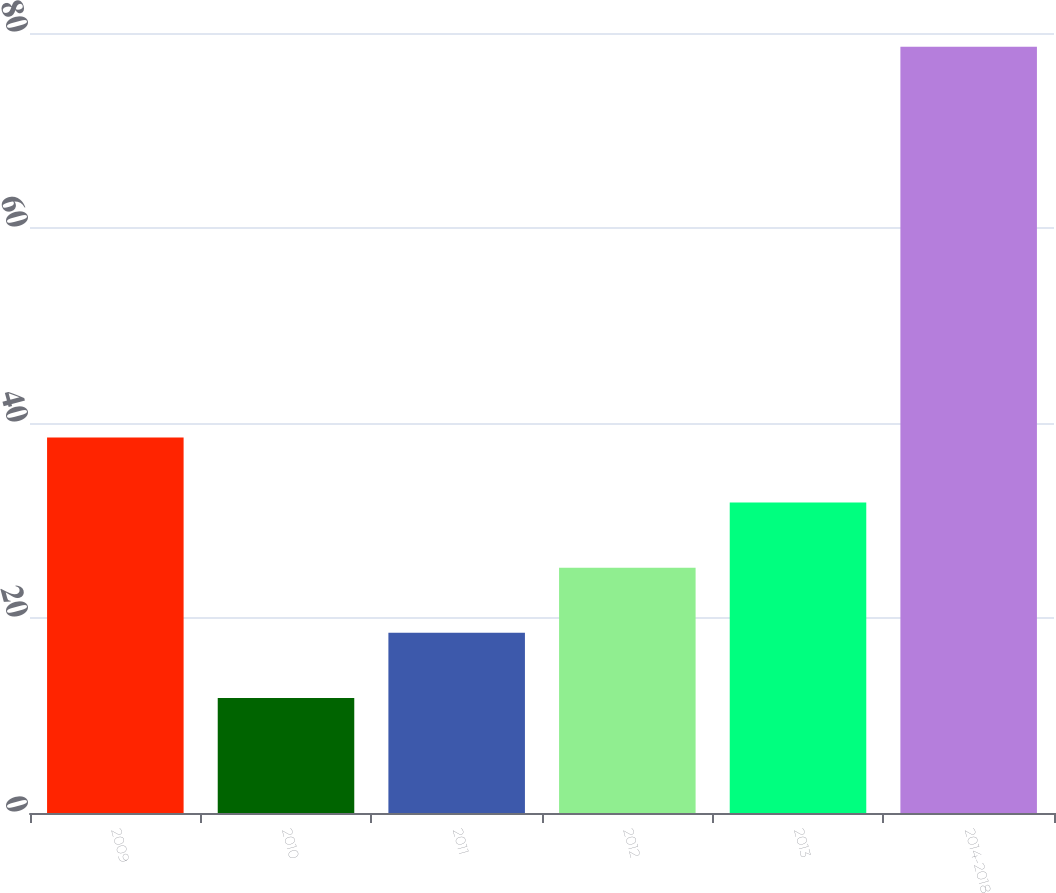<chart> <loc_0><loc_0><loc_500><loc_500><bar_chart><fcel>2009<fcel>2010<fcel>2011<fcel>2012<fcel>2013<fcel>2014-2018<nl><fcel>38.52<fcel>11.8<fcel>18.48<fcel>25.16<fcel>31.84<fcel>78.6<nl></chart> 